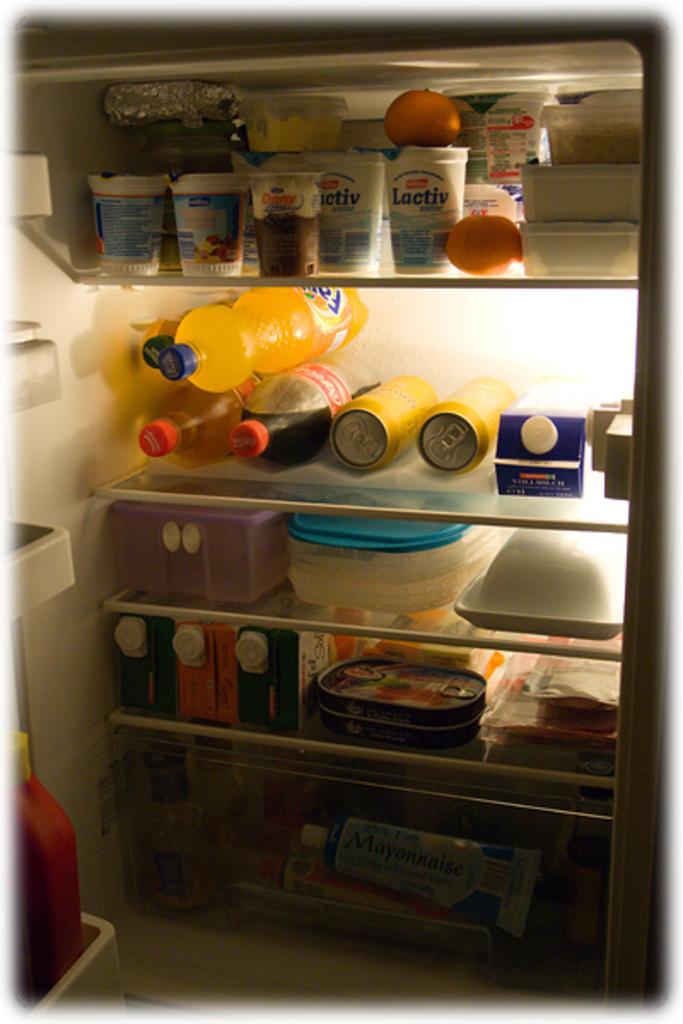What brand is the container with the orange on top of it?
Offer a terse response. Lactiv. 